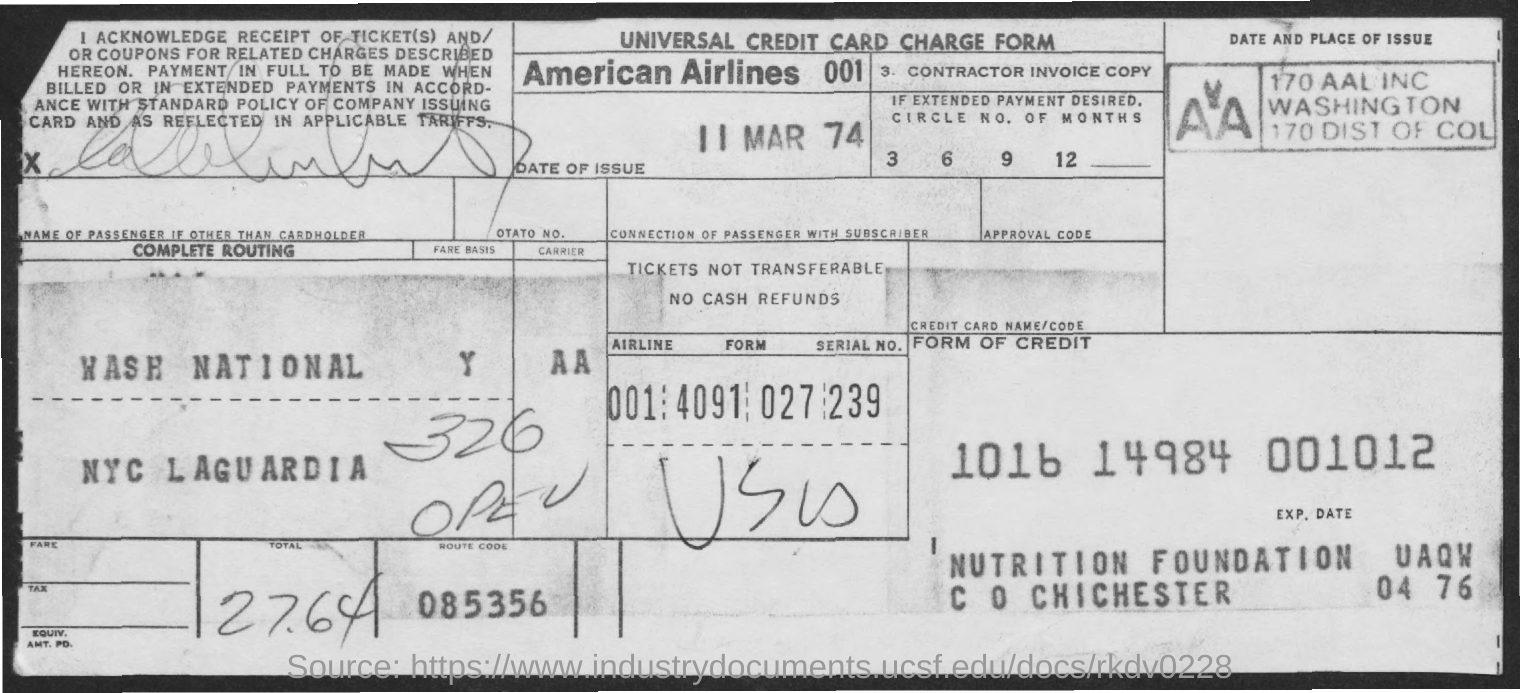Give some essential details in this illustration. This document is a Universal Credit card charge form. The route code is 085356. The total amount is 27.64 dollars. What is the date of issue? March 11, 1974. The American Airlines is the name of an airline company. 